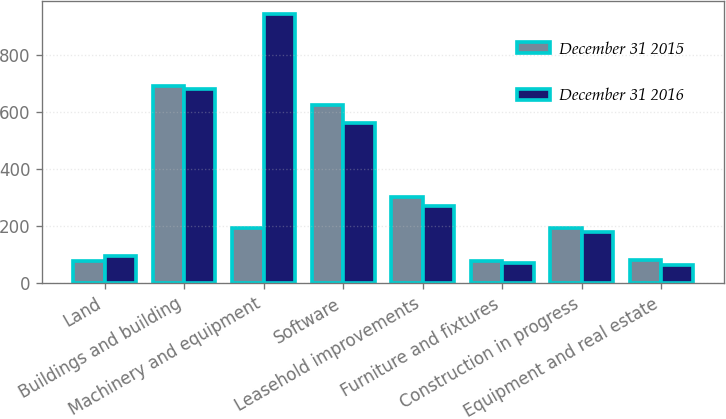<chart> <loc_0><loc_0><loc_500><loc_500><stacked_bar_chart><ecel><fcel>Land<fcel>Buildings and building<fcel>Machinery and equipment<fcel>Software<fcel>Leasehold improvements<fcel>Furniture and fixtures<fcel>Construction in progress<fcel>Equipment and real estate<nl><fcel>December 31 2015<fcel>78.4<fcel>692.8<fcel>193<fcel>626.2<fcel>302<fcel>76.9<fcel>193<fcel>81.3<nl><fcel>December 31 2016<fcel>96.4<fcel>681.6<fcel>944.2<fcel>561.9<fcel>271.6<fcel>70.1<fcel>180.4<fcel>65.1<nl></chart> 